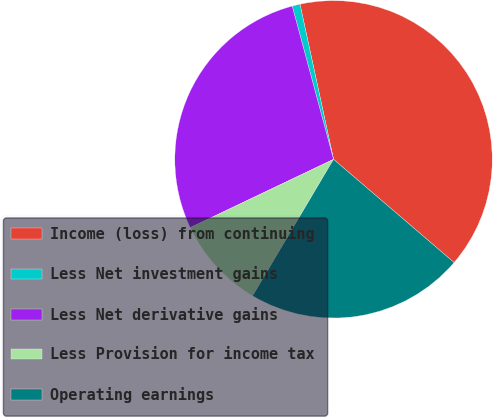Convert chart to OTSL. <chart><loc_0><loc_0><loc_500><loc_500><pie_chart><fcel>Income (loss) from continuing<fcel>Less Net investment gains<fcel>Less Net derivative gains<fcel>Less Provision for income tax<fcel>Operating earnings<nl><fcel>39.66%<fcel>0.8%<fcel>27.89%<fcel>9.4%<fcel>22.25%<nl></chart> 